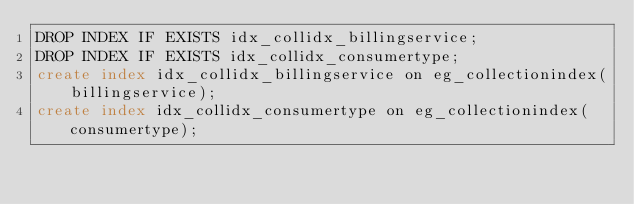<code> <loc_0><loc_0><loc_500><loc_500><_SQL_>DROP INDEX IF EXISTS idx_collidx_billingservice;
DROP INDEX IF EXISTS idx_collidx_consumertype;
create index idx_collidx_billingservice on eg_collectionindex(billingservice);
create index idx_collidx_consumertype on eg_collectionindex(consumertype);
</code> 